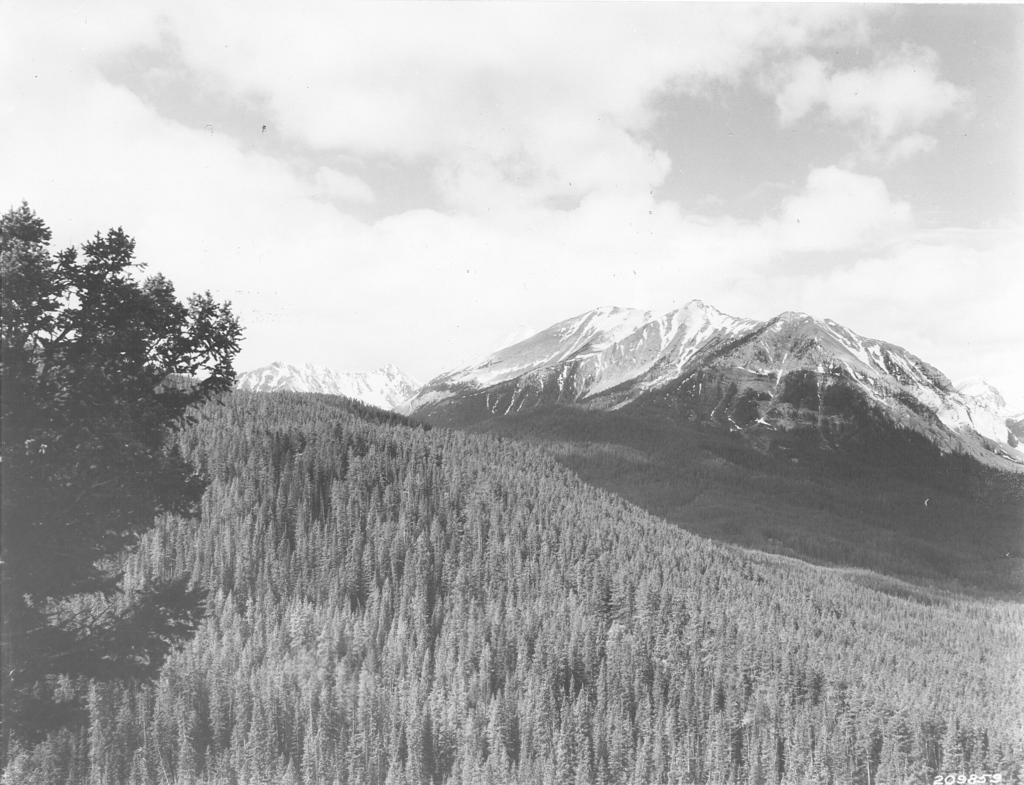What types of vegetation are in the foreground of the image? There are plants and trees in the foreground of the image. What type of landscape can be seen in the background of the image? There are snow mountains in the background of the image. What is the condition of the sky in the background of the image? The sky is cloudy in the background of the image. What type of produce is being cooked on the stove in the image? There is no stove or produce present in the image. Can you tell me how many zebras are grazing in the foreground of the image? There are no zebras present in the image; it features plants and trees in the foreground. 